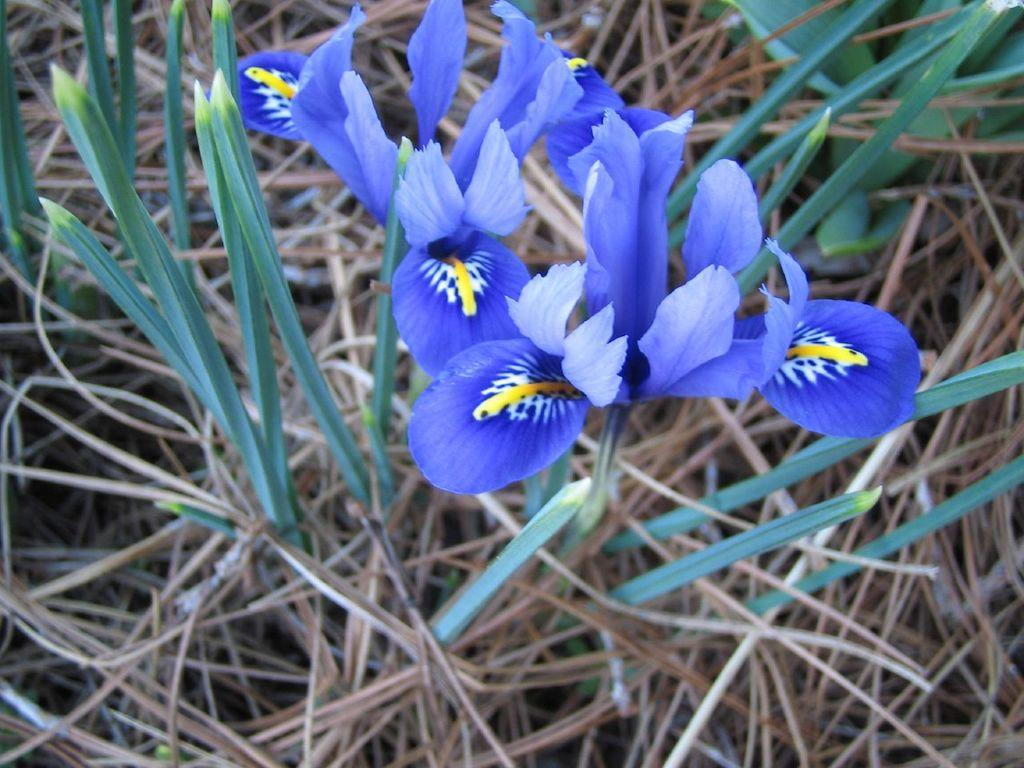What type of plants can be seen in the image? There are flowers and leaves in the image. What is the condition of the grass in the image? There is dried grass in the image. Can you tell me how many boys are flying a kite in the image? There are no boys or kites present in the image. Is there a stranger interacting with the flowers in the image? There is no stranger present in the image. 